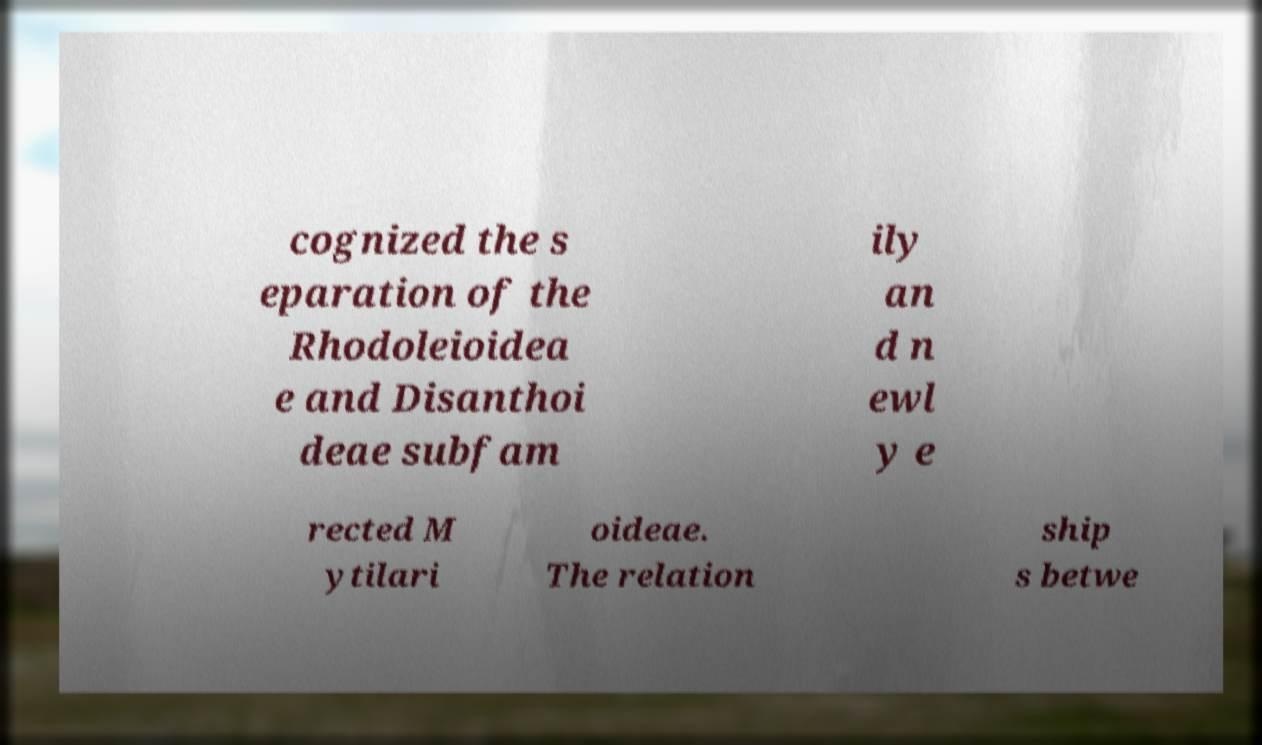What messages or text are displayed in this image? I need them in a readable, typed format. cognized the s eparation of the Rhodoleioidea e and Disanthoi deae subfam ily an d n ewl y e rected M ytilari oideae. The relation ship s betwe 